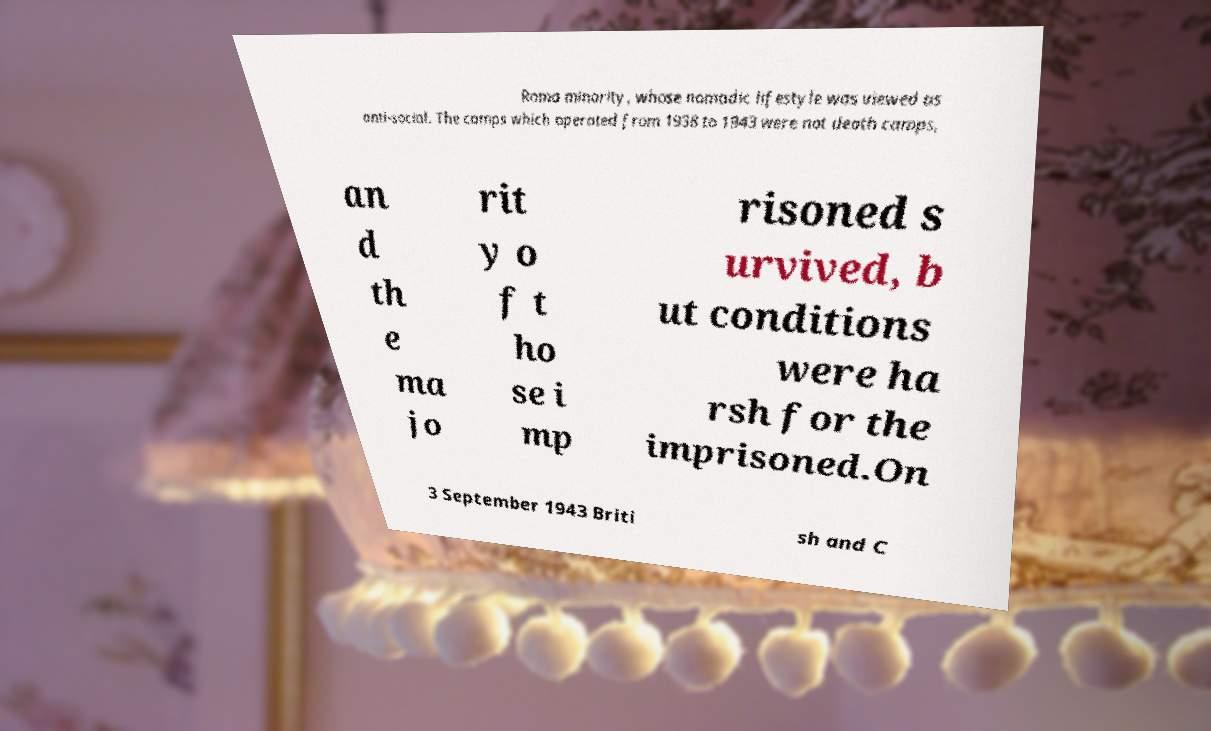Could you assist in decoding the text presented in this image and type it out clearly? Roma minority, whose nomadic lifestyle was viewed as anti-social. The camps which operated from 1938 to 1943 were not death camps, an d th e ma jo rit y o f t ho se i mp risoned s urvived, b ut conditions were ha rsh for the imprisoned.On 3 September 1943 Briti sh and C 